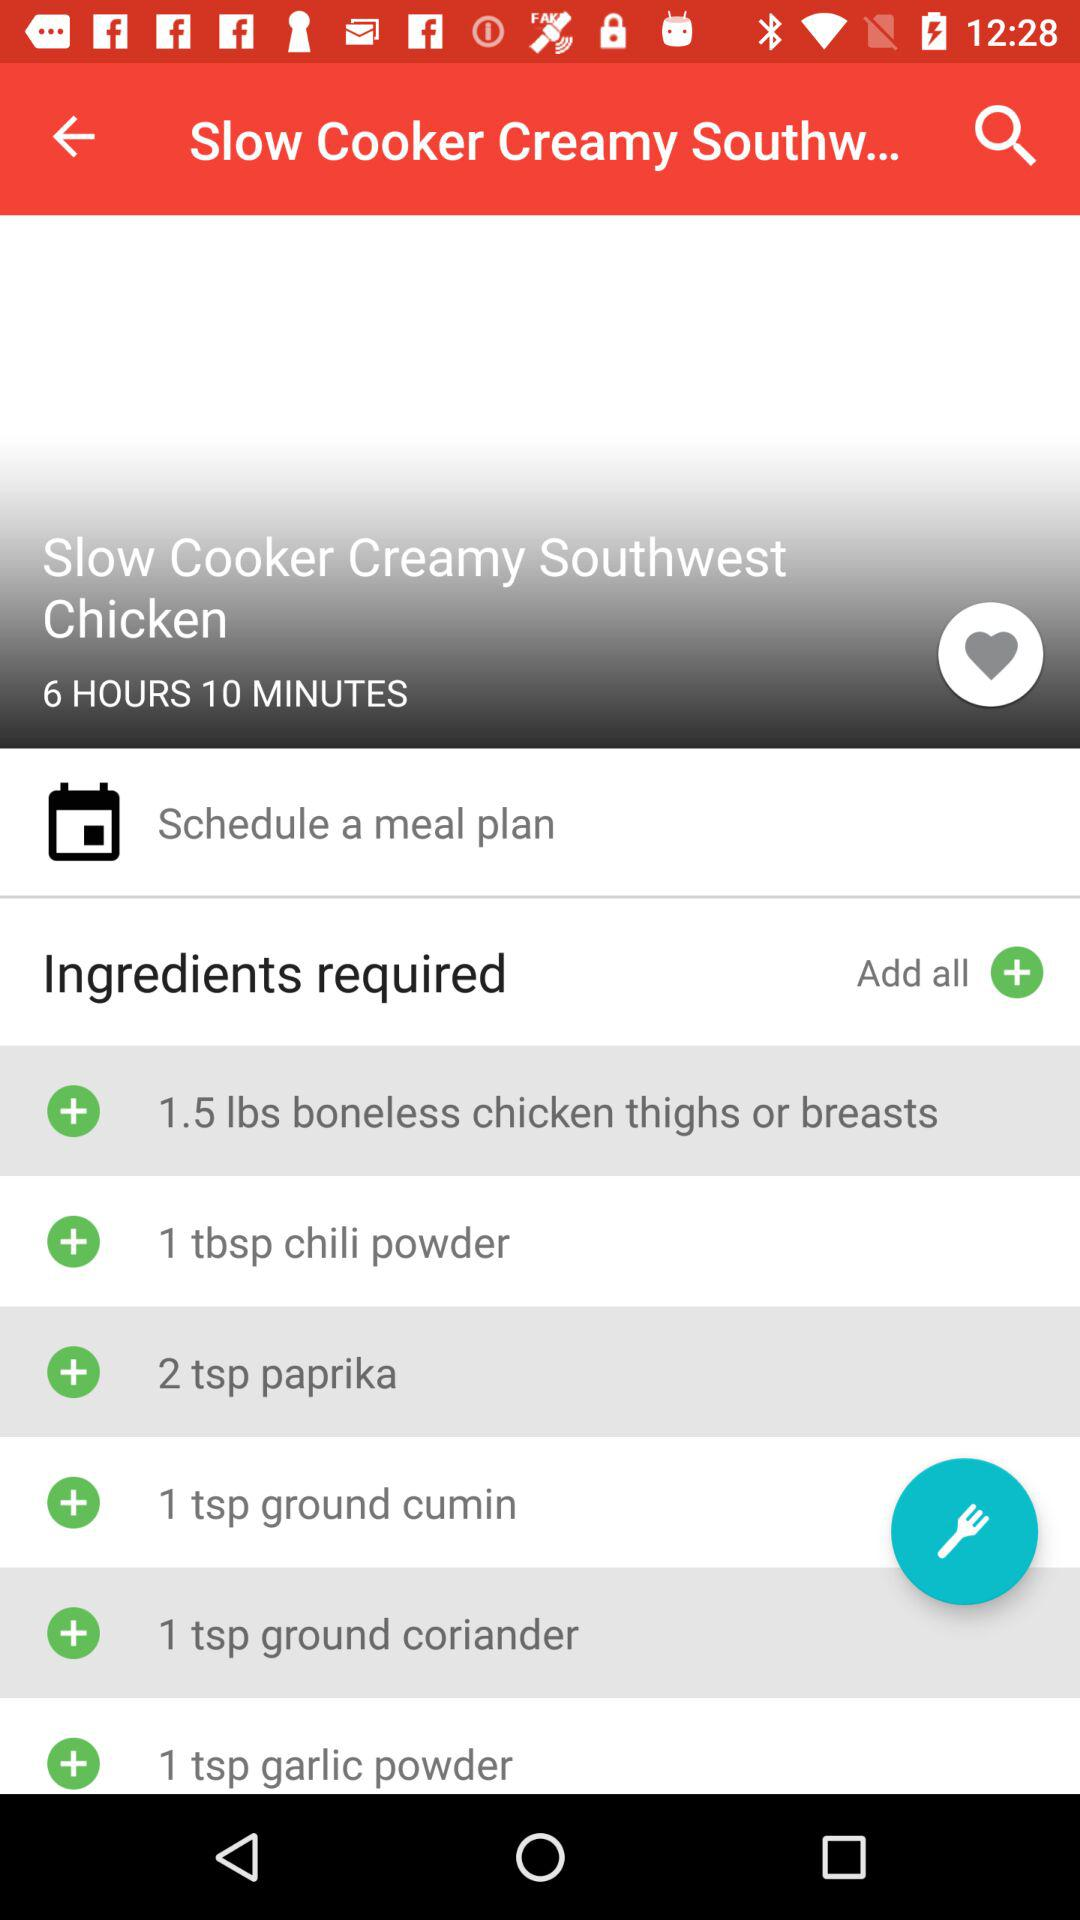How long does the Slow Cooker Creamy Southwest Chicken take to cook? The Slow Cooker Creamy Southwest Chicken takes 6 hours and 10 minutes to cook. 